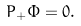<formula> <loc_0><loc_0><loc_500><loc_500>P _ { + } \Phi = 0 .</formula> 